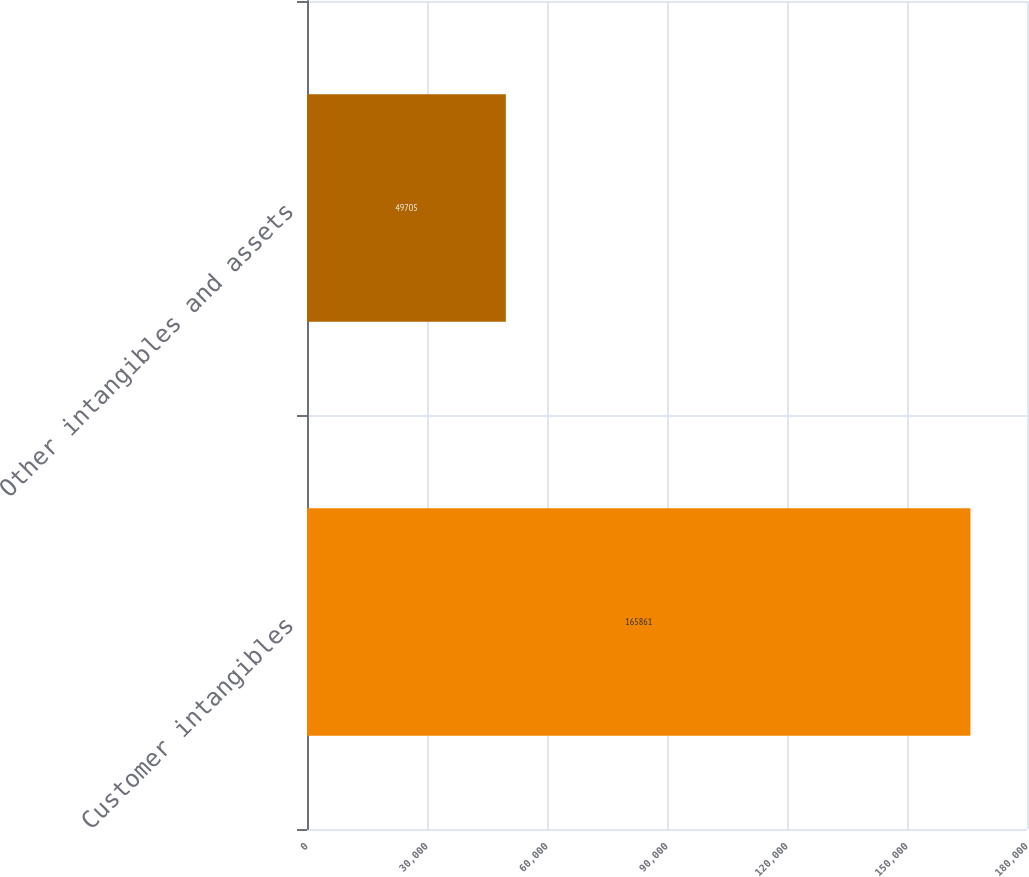<chart> <loc_0><loc_0><loc_500><loc_500><bar_chart><fcel>Customer intangibles<fcel>Other intangibles and assets<nl><fcel>165861<fcel>49705<nl></chart> 